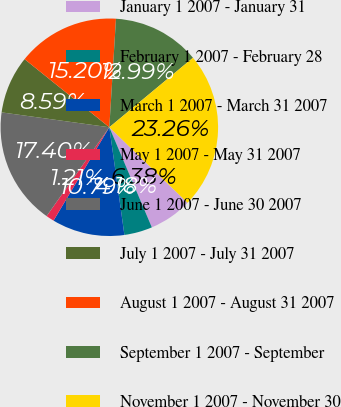Convert chart. <chart><loc_0><loc_0><loc_500><loc_500><pie_chart><fcel>January 1 2007 - January 31<fcel>February 1 2007 - February 28<fcel>March 1 2007 - March 31 2007<fcel>May 1 2007 - May 31 2007<fcel>June 1 2007 - June 30 2007<fcel>July 1 2007 - July 31 2007<fcel>August 1 2007 - August 31 2007<fcel>September 1 2007 - September<fcel>November 1 2007 - November 30<nl><fcel>6.38%<fcel>4.18%<fcel>10.79%<fcel>1.21%<fcel>17.4%<fcel>8.59%<fcel>15.2%<fcel>12.99%<fcel>23.26%<nl></chart> 